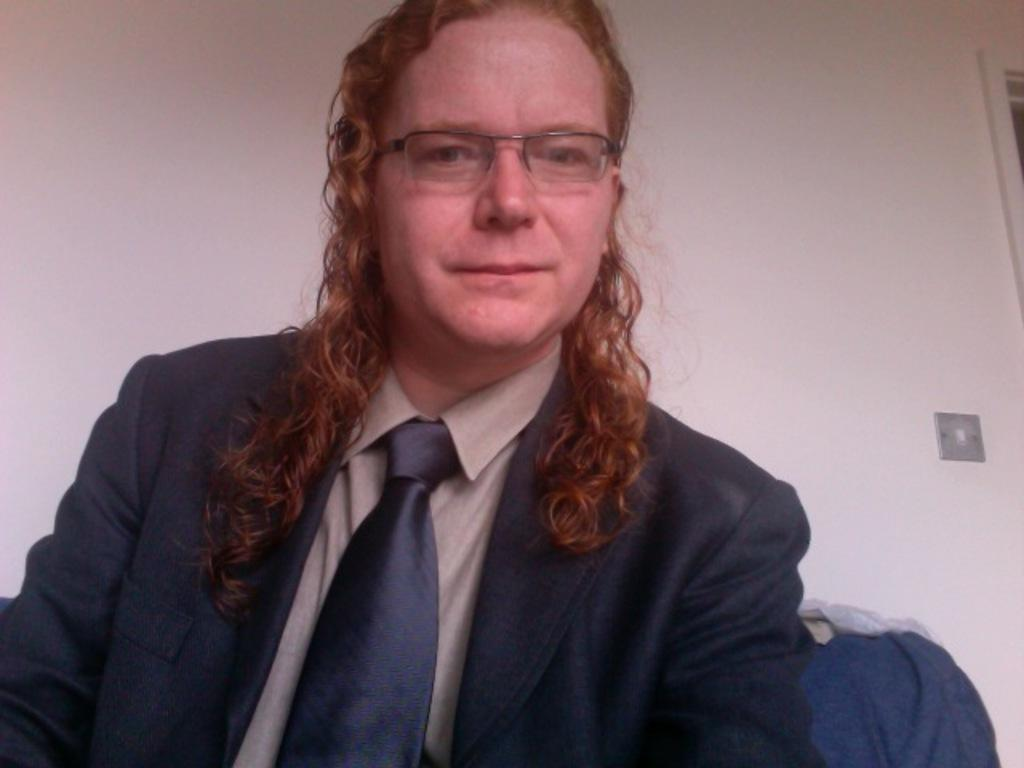Who is present in the image? There is a man in the image. What accessory is the man wearing? The man is wearing glasses. What can be seen in the background of the image? There are clothes visible in the background of the image. What type of birds can be seen flying in the image? There are no birds visible in the image. 